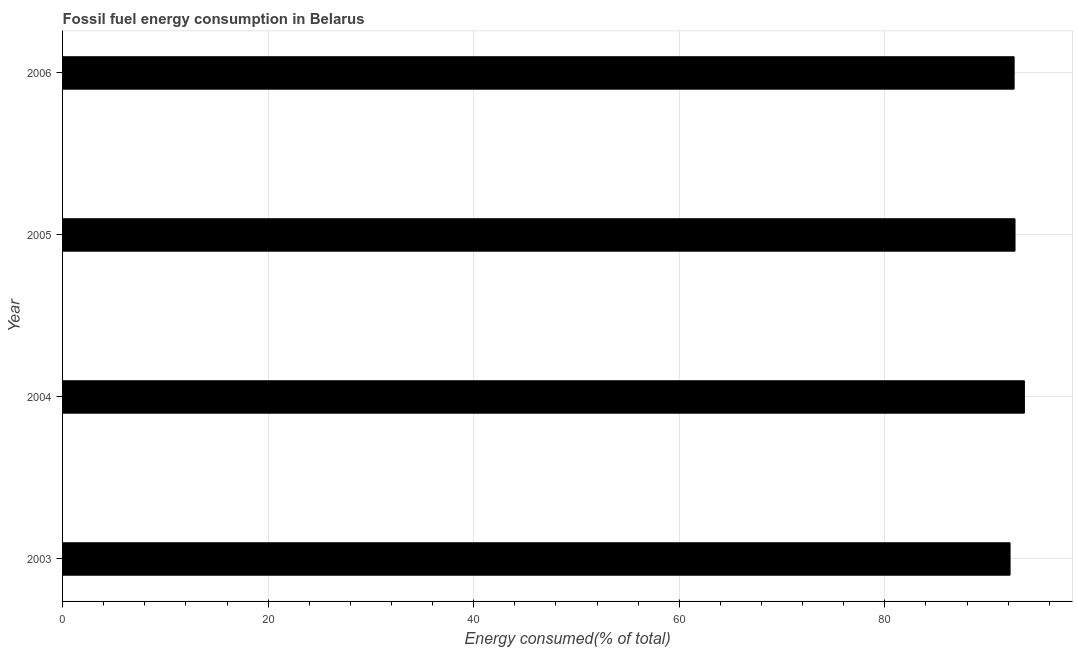Does the graph contain any zero values?
Your response must be concise. No. Does the graph contain grids?
Your answer should be very brief. Yes. What is the title of the graph?
Your response must be concise. Fossil fuel energy consumption in Belarus. What is the label or title of the X-axis?
Provide a short and direct response. Energy consumed(% of total). What is the label or title of the Y-axis?
Provide a short and direct response. Year. What is the fossil fuel energy consumption in 2005?
Make the answer very short. 92.67. Across all years, what is the maximum fossil fuel energy consumption?
Your answer should be compact. 93.59. Across all years, what is the minimum fossil fuel energy consumption?
Offer a very short reply. 92.19. In which year was the fossil fuel energy consumption maximum?
Ensure brevity in your answer.  2004. In which year was the fossil fuel energy consumption minimum?
Make the answer very short. 2003. What is the sum of the fossil fuel energy consumption?
Provide a succinct answer. 371.03. What is the difference between the fossil fuel energy consumption in 2003 and 2005?
Offer a terse response. -0.48. What is the average fossil fuel energy consumption per year?
Your response must be concise. 92.76. What is the median fossil fuel energy consumption?
Keep it short and to the point. 92.63. Is the difference between the fossil fuel energy consumption in 2004 and 2005 greater than the difference between any two years?
Ensure brevity in your answer.  No. What is the difference between the highest and the lowest fossil fuel energy consumption?
Provide a short and direct response. 1.39. How many bars are there?
Ensure brevity in your answer.  4. Are all the bars in the graph horizontal?
Offer a very short reply. Yes. How many years are there in the graph?
Make the answer very short. 4. What is the difference between two consecutive major ticks on the X-axis?
Ensure brevity in your answer.  20. What is the Energy consumed(% of total) of 2003?
Ensure brevity in your answer.  92.19. What is the Energy consumed(% of total) in 2004?
Your answer should be compact. 93.59. What is the Energy consumed(% of total) of 2005?
Your response must be concise. 92.67. What is the Energy consumed(% of total) of 2006?
Offer a very short reply. 92.58. What is the difference between the Energy consumed(% of total) in 2003 and 2004?
Ensure brevity in your answer.  -1.39. What is the difference between the Energy consumed(% of total) in 2003 and 2005?
Provide a succinct answer. -0.48. What is the difference between the Energy consumed(% of total) in 2003 and 2006?
Your answer should be compact. -0.39. What is the difference between the Energy consumed(% of total) in 2004 and 2005?
Your answer should be compact. 0.91. What is the difference between the Energy consumed(% of total) in 2004 and 2006?
Ensure brevity in your answer.  1. What is the difference between the Energy consumed(% of total) in 2005 and 2006?
Provide a short and direct response. 0.09. What is the ratio of the Energy consumed(% of total) in 2003 to that in 2004?
Give a very brief answer. 0.98. What is the ratio of the Energy consumed(% of total) in 2003 to that in 2005?
Make the answer very short. 0.99. What is the ratio of the Energy consumed(% of total) in 2003 to that in 2006?
Your answer should be very brief. 1. What is the ratio of the Energy consumed(% of total) in 2004 to that in 2005?
Your answer should be compact. 1.01. What is the ratio of the Energy consumed(% of total) in 2004 to that in 2006?
Offer a very short reply. 1.01. 